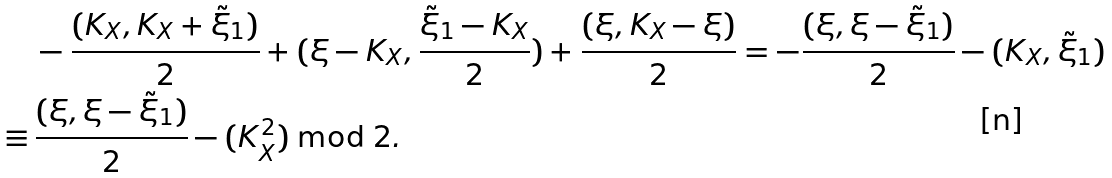<formula> <loc_0><loc_0><loc_500><loc_500>& - \frac { ( K _ { X } , K _ { X } + \tilde { \xi } _ { 1 } ) } 2 + ( \xi - K _ { X } , \frac { \tilde { \xi } _ { 1 } - K _ { X } } 2 ) + \frac { ( \xi , K _ { X } - \xi ) } 2 = - \frac { ( \xi , \xi - \tilde { \xi } _ { 1 } ) } 2 - ( K _ { X } , \tilde { \xi } _ { 1 } ) \\ \equiv \, & \frac { ( \xi , \xi - \tilde { \xi } _ { 1 } ) } 2 - ( K _ { X } ^ { 2 } ) \bmod 2 .</formula> 